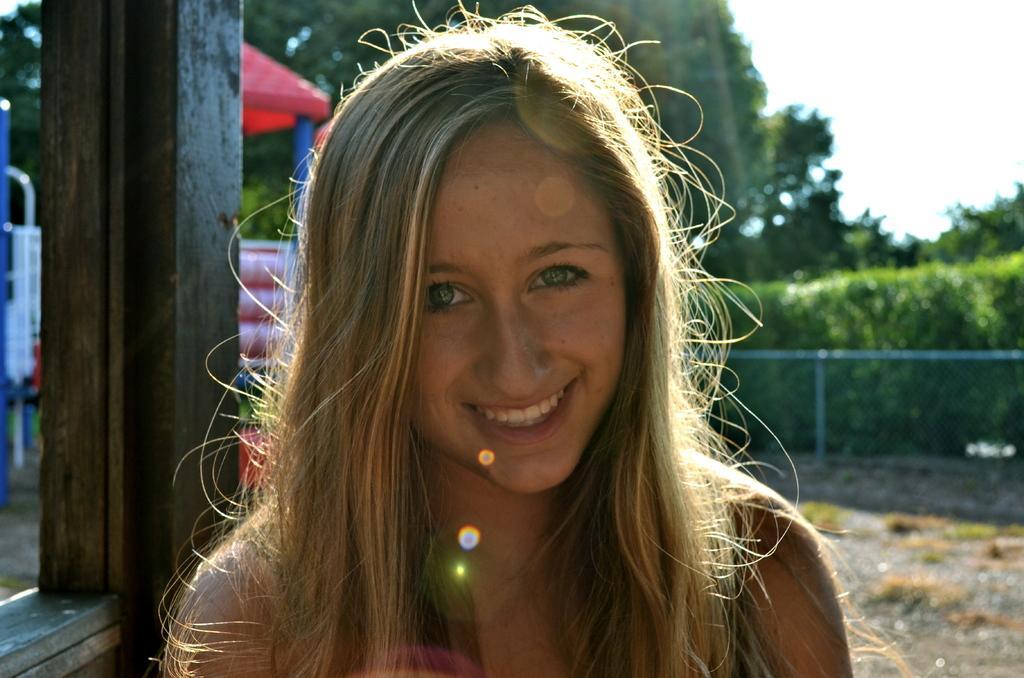Describe this image in one or two sentences. There is a woman smiling. In the background, there is a red color tint, there are plants, fencing, trees and there is sky. 